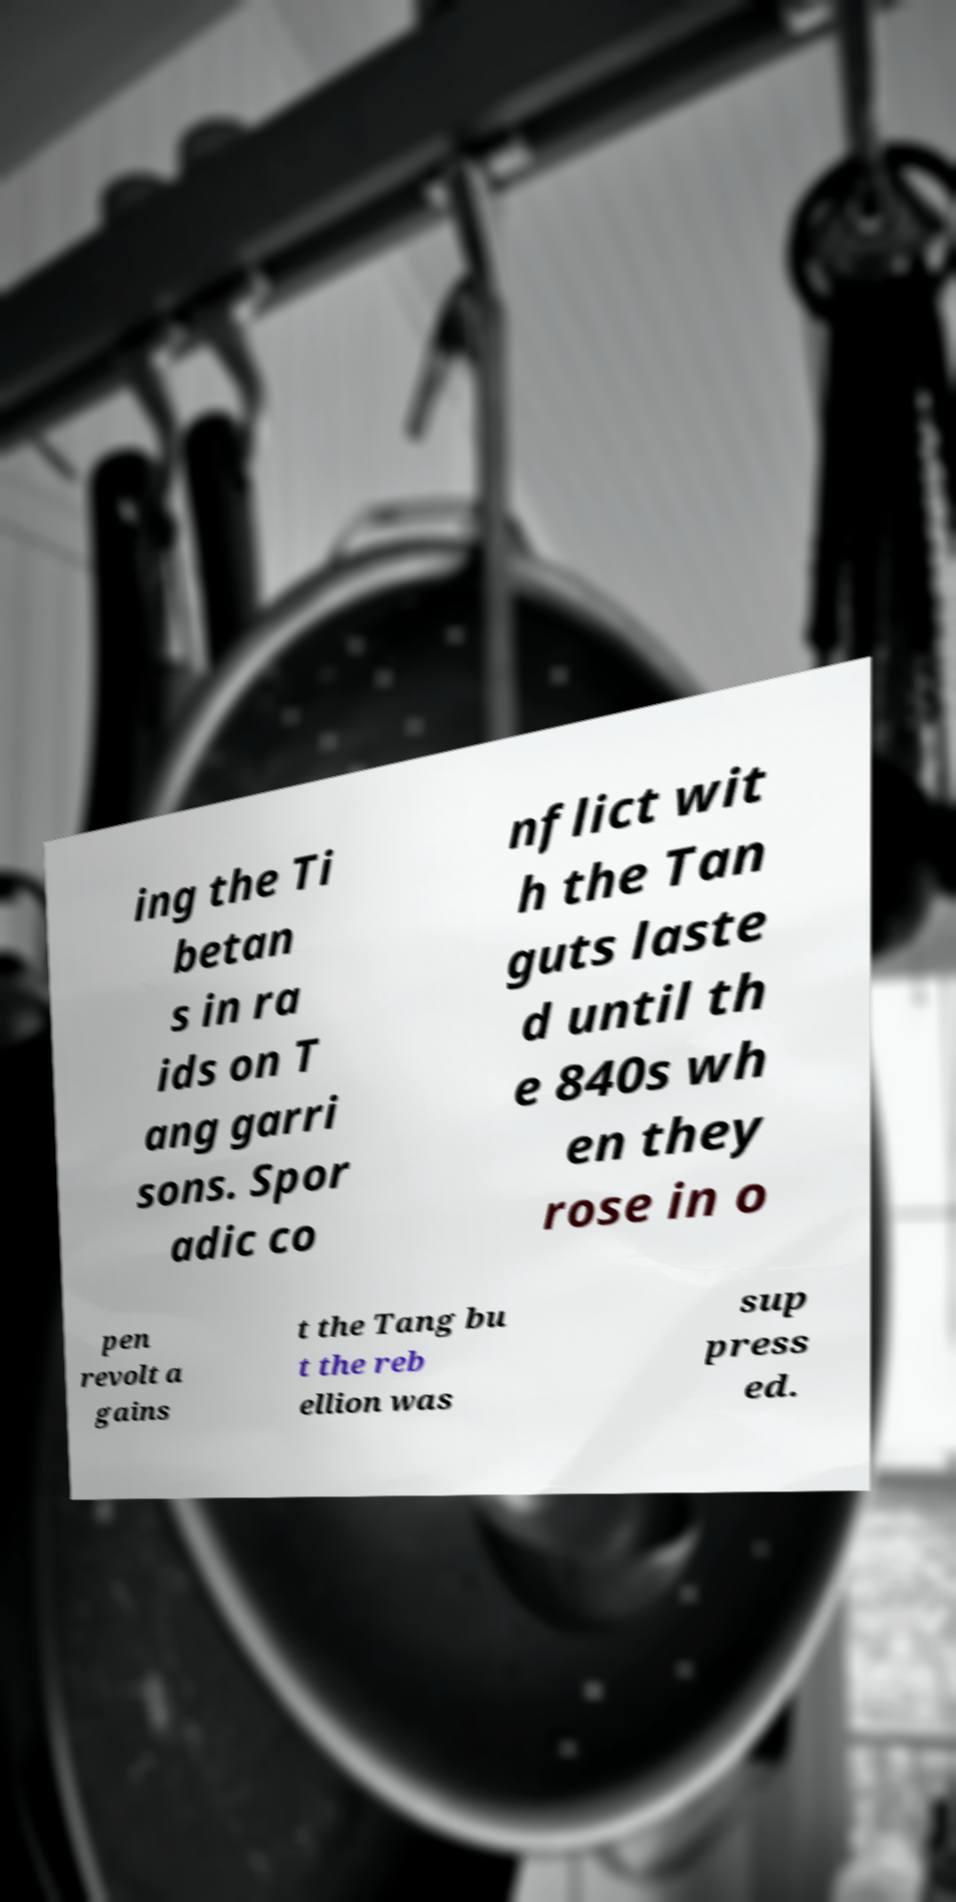Can you read and provide the text displayed in the image?This photo seems to have some interesting text. Can you extract and type it out for me? ing the Ti betan s in ra ids on T ang garri sons. Spor adic co nflict wit h the Tan guts laste d until th e 840s wh en they rose in o pen revolt a gains t the Tang bu t the reb ellion was sup press ed. 